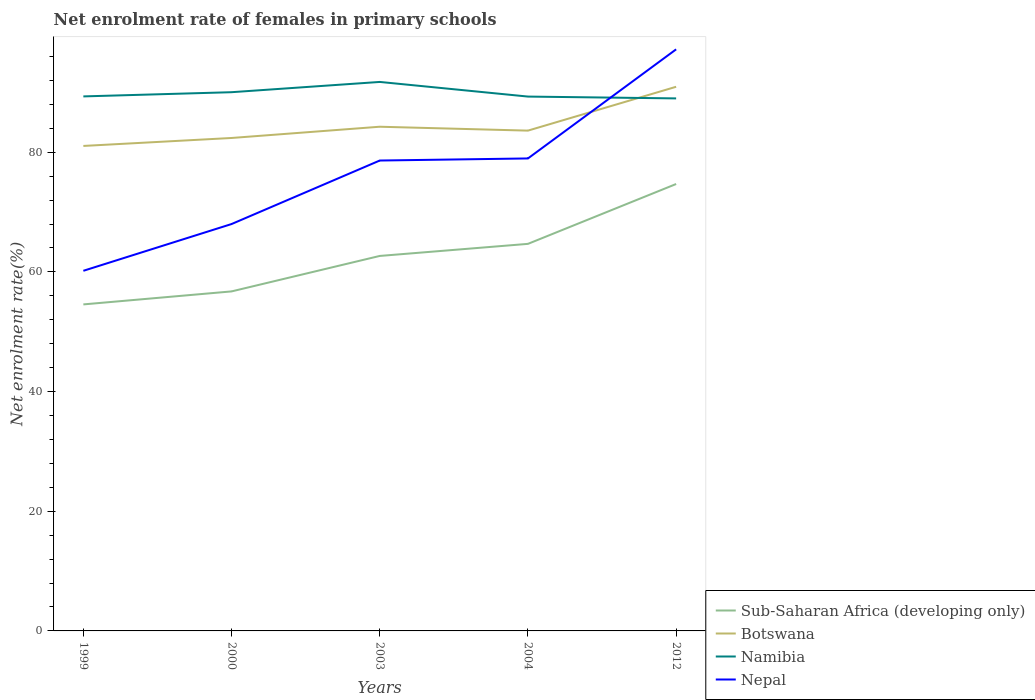How many different coloured lines are there?
Your response must be concise. 4. Is the number of lines equal to the number of legend labels?
Offer a very short reply. Yes. Across all years, what is the maximum net enrolment rate of females in primary schools in Sub-Saharan Africa (developing only)?
Make the answer very short. 54.56. What is the total net enrolment rate of females in primary schools in Botswana in the graph?
Your answer should be compact. -1.23. What is the difference between the highest and the second highest net enrolment rate of females in primary schools in Botswana?
Make the answer very short. 9.89. What is the difference between the highest and the lowest net enrolment rate of females in primary schools in Namibia?
Keep it short and to the point. 2. What is the difference between two consecutive major ticks on the Y-axis?
Provide a short and direct response. 20. Does the graph contain grids?
Make the answer very short. No. Where does the legend appear in the graph?
Provide a short and direct response. Bottom right. What is the title of the graph?
Offer a very short reply. Net enrolment rate of females in primary schools. Does "South Asia" appear as one of the legend labels in the graph?
Provide a succinct answer. No. What is the label or title of the X-axis?
Your response must be concise. Years. What is the label or title of the Y-axis?
Give a very brief answer. Net enrolment rate(%). What is the Net enrolment rate(%) of Sub-Saharan Africa (developing only) in 1999?
Ensure brevity in your answer.  54.56. What is the Net enrolment rate(%) of Botswana in 1999?
Give a very brief answer. 81.05. What is the Net enrolment rate(%) in Namibia in 1999?
Your answer should be compact. 89.32. What is the Net enrolment rate(%) of Nepal in 1999?
Provide a short and direct response. 60.18. What is the Net enrolment rate(%) in Sub-Saharan Africa (developing only) in 2000?
Ensure brevity in your answer.  56.74. What is the Net enrolment rate(%) of Botswana in 2000?
Your answer should be very brief. 82.38. What is the Net enrolment rate(%) in Namibia in 2000?
Your response must be concise. 90.03. What is the Net enrolment rate(%) in Nepal in 2000?
Offer a very short reply. 67.99. What is the Net enrolment rate(%) in Sub-Saharan Africa (developing only) in 2003?
Your answer should be compact. 62.66. What is the Net enrolment rate(%) of Botswana in 2003?
Make the answer very short. 84.26. What is the Net enrolment rate(%) in Namibia in 2003?
Offer a terse response. 91.74. What is the Net enrolment rate(%) in Nepal in 2003?
Your answer should be compact. 78.61. What is the Net enrolment rate(%) of Sub-Saharan Africa (developing only) in 2004?
Give a very brief answer. 64.68. What is the Net enrolment rate(%) of Botswana in 2004?
Keep it short and to the point. 83.61. What is the Net enrolment rate(%) of Namibia in 2004?
Offer a terse response. 89.29. What is the Net enrolment rate(%) of Nepal in 2004?
Give a very brief answer. 78.96. What is the Net enrolment rate(%) in Sub-Saharan Africa (developing only) in 2012?
Offer a very short reply. 74.68. What is the Net enrolment rate(%) in Botswana in 2012?
Ensure brevity in your answer.  90.93. What is the Net enrolment rate(%) of Namibia in 2012?
Ensure brevity in your answer.  88.99. What is the Net enrolment rate(%) of Nepal in 2012?
Ensure brevity in your answer.  97.19. Across all years, what is the maximum Net enrolment rate(%) of Sub-Saharan Africa (developing only)?
Ensure brevity in your answer.  74.68. Across all years, what is the maximum Net enrolment rate(%) of Botswana?
Provide a succinct answer. 90.93. Across all years, what is the maximum Net enrolment rate(%) of Namibia?
Your answer should be compact. 91.74. Across all years, what is the maximum Net enrolment rate(%) in Nepal?
Give a very brief answer. 97.19. Across all years, what is the minimum Net enrolment rate(%) of Sub-Saharan Africa (developing only)?
Ensure brevity in your answer.  54.56. Across all years, what is the minimum Net enrolment rate(%) in Botswana?
Ensure brevity in your answer.  81.05. Across all years, what is the minimum Net enrolment rate(%) in Namibia?
Ensure brevity in your answer.  88.99. Across all years, what is the minimum Net enrolment rate(%) in Nepal?
Offer a terse response. 60.18. What is the total Net enrolment rate(%) of Sub-Saharan Africa (developing only) in the graph?
Your answer should be very brief. 313.33. What is the total Net enrolment rate(%) in Botswana in the graph?
Offer a very short reply. 422.21. What is the total Net enrolment rate(%) in Namibia in the graph?
Your response must be concise. 449.37. What is the total Net enrolment rate(%) of Nepal in the graph?
Make the answer very short. 382.92. What is the difference between the Net enrolment rate(%) of Sub-Saharan Africa (developing only) in 1999 and that in 2000?
Provide a succinct answer. -2.17. What is the difference between the Net enrolment rate(%) in Botswana in 1999 and that in 2000?
Keep it short and to the point. -1.33. What is the difference between the Net enrolment rate(%) of Namibia in 1999 and that in 2000?
Provide a succinct answer. -0.7. What is the difference between the Net enrolment rate(%) in Nepal in 1999 and that in 2000?
Your answer should be compact. -7.81. What is the difference between the Net enrolment rate(%) in Sub-Saharan Africa (developing only) in 1999 and that in 2003?
Make the answer very short. -8.1. What is the difference between the Net enrolment rate(%) in Botswana in 1999 and that in 2003?
Give a very brief answer. -3.21. What is the difference between the Net enrolment rate(%) of Namibia in 1999 and that in 2003?
Keep it short and to the point. -2.42. What is the difference between the Net enrolment rate(%) of Nepal in 1999 and that in 2003?
Your response must be concise. -18.43. What is the difference between the Net enrolment rate(%) of Sub-Saharan Africa (developing only) in 1999 and that in 2004?
Keep it short and to the point. -10.12. What is the difference between the Net enrolment rate(%) of Botswana in 1999 and that in 2004?
Offer a very short reply. -2.56. What is the difference between the Net enrolment rate(%) of Namibia in 1999 and that in 2004?
Ensure brevity in your answer.  0.03. What is the difference between the Net enrolment rate(%) of Nepal in 1999 and that in 2004?
Give a very brief answer. -18.78. What is the difference between the Net enrolment rate(%) of Sub-Saharan Africa (developing only) in 1999 and that in 2012?
Provide a short and direct response. -20.12. What is the difference between the Net enrolment rate(%) of Botswana in 1999 and that in 2012?
Your answer should be compact. -9.89. What is the difference between the Net enrolment rate(%) in Namibia in 1999 and that in 2012?
Your answer should be very brief. 0.33. What is the difference between the Net enrolment rate(%) of Nepal in 1999 and that in 2012?
Offer a very short reply. -37.01. What is the difference between the Net enrolment rate(%) in Sub-Saharan Africa (developing only) in 2000 and that in 2003?
Your answer should be very brief. -5.93. What is the difference between the Net enrolment rate(%) in Botswana in 2000 and that in 2003?
Provide a succinct answer. -1.88. What is the difference between the Net enrolment rate(%) in Namibia in 2000 and that in 2003?
Provide a short and direct response. -1.72. What is the difference between the Net enrolment rate(%) in Nepal in 2000 and that in 2003?
Your response must be concise. -10.61. What is the difference between the Net enrolment rate(%) in Sub-Saharan Africa (developing only) in 2000 and that in 2004?
Your response must be concise. -7.94. What is the difference between the Net enrolment rate(%) in Botswana in 2000 and that in 2004?
Ensure brevity in your answer.  -1.23. What is the difference between the Net enrolment rate(%) in Namibia in 2000 and that in 2004?
Ensure brevity in your answer.  0.73. What is the difference between the Net enrolment rate(%) of Nepal in 2000 and that in 2004?
Your answer should be very brief. -10.96. What is the difference between the Net enrolment rate(%) of Sub-Saharan Africa (developing only) in 2000 and that in 2012?
Make the answer very short. -17.95. What is the difference between the Net enrolment rate(%) of Botswana in 2000 and that in 2012?
Give a very brief answer. -8.56. What is the difference between the Net enrolment rate(%) in Namibia in 2000 and that in 2012?
Ensure brevity in your answer.  1.04. What is the difference between the Net enrolment rate(%) of Nepal in 2000 and that in 2012?
Your response must be concise. -29.2. What is the difference between the Net enrolment rate(%) of Sub-Saharan Africa (developing only) in 2003 and that in 2004?
Offer a terse response. -2.02. What is the difference between the Net enrolment rate(%) in Botswana in 2003 and that in 2004?
Your response must be concise. 0.65. What is the difference between the Net enrolment rate(%) in Namibia in 2003 and that in 2004?
Provide a short and direct response. 2.45. What is the difference between the Net enrolment rate(%) in Nepal in 2003 and that in 2004?
Give a very brief answer. -0.35. What is the difference between the Net enrolment rate(%) of Sub-Saharan Africa (developing only) in 2003 and that in 2012?
Offer a terse response. -12.02. What is the difference between the Net enrolment rate(%) of Botswana in 2003 and that in 2012?
Offer a very short reply. -6.68. What is the difference between the Net enrolment rate(%) in Namibia in 2003 and that in 2012?
Provide a succinct answer. 2.75. What is the difference between the Net enrolment rate(%) in Nepal in 2003 and that in 2012?
Offer a very short reply. -18.58. What is the difference between the Net enrolment rate(%) in Sub-Saharan Africa (developing only) in 2004 and that in 2012?
Your answer should be very brief. -10. What is the difference between the Net enrolment rate(%) in Botswana in 2004 and that in 2012?
Provide a short and direct response. -7.33. What is the difference between the Net enrolment rate(%) of Namibia in 2004 and that in 2012?
Ensure brevity in your answer.  0.31. What is the difference between the Net enrolment rate(%) in Nepal in 2004 and that in 2012?
Provide a short and direct response. -18.23. What is the difference between the Net enrolment rate(%) in Sub-Saharan Africa (developing only) in 1999 and the Net enrolment rate(%) in Botswana in 2000?
Keep it short and to the point. -27.81. What is the difference between the Net enrolment rate(%) of Sub-Saharan Africa (developing only) in 1999 and the Net enrolment rate(%) of Namibia in 2000?
Make the answer very short. -35.46. What is the difference between the Net enrolment rate(%) of Sub-Saharan Africa (developing only) in 1999 and the Net enrolment rate(%) of Nepal in 2000?
Make the answer very short. -13.43. What is the difference between the Net enrolment rate(%) in Botswana in 1999 and the Net enrolment rate(%) in Namibia in 2000?
Provide a short and direct response. -8.98. What is the difference between the Net enrolment rate(%) in Botswana in 1999 and the Net enrolment rate(%) in Nepal in 2000?
Provide a short and direct response. 13.05. What is the difference between the Net enrolment rate(%) of Namibia in 1999 and the Net enrolment rate(%) of Nepal in 2000?
Provide a succinct answer. 21.33. What is the difference between the Net enrolment rate(%) in Sub-Saharan Africa (developing only) in 1999 and the Net enrolment rate(%) in Botswana in 2003?
Ensure brevity in your answer.  -29.69. What is the difference between the Net enrolment rate(%) of Sub-Saharan Africa (developing only) in 1999 and the Net enrolment rate(%) of Namibia in 2003?
Give a very brief answer. -37.18. What is the difference between the Net enrolment rate(%) in Sub-Saharan Africa (developing only) in 1999 and the Net enrolment rate(%) in Nepal in 2003?
Provide a succinct answer. -24.04. What is the difference between the Net enrolment rate(%) of Botswana in 1999 and the Net enrolment rate(%) of Namibia in 2003?
Offer a very short reply. -10.7. What is the difference between the Net enrolment rate(%) of Botswana in 1999 and the Net enrolment rate(%) of Nepal in 2003?
Provide a succinct answer. 2.44. What is the difference between the Net enrolment rate(%) in Namibia in 1999 and the Net enrolment rate(%) in Nepal in 2003?
Offer a very short reply. 10.72. What is the difference between the Net enrolment rate(%) in Sub-Saharan Africa (developing only) in 1999 and the Net enrolment rate(%) in Botswana in 2004?
Ensure brevity in your answer.  -29.04. What is the difference between the Net enrolment rate(%) of Sub-Saharan Africa (developing only) in 1999 and the Net enrolment rate(%) of Namibia in 2004?
Your response must be concise. -34.73. What is the difference between the Net enrolment rate(%) in Sub-Saharan Africa (developing only) in 1999 and the Net enrolment rate(%) in Nepal in 2004?
Keep it short and to the point. -24.39. What is the difference between the Net enrolment rate(%) in Botswana in 1999 and the Net enrolment rate(%) in Namibia in 2004?
Offer a terse response. -8.25. What is the difference between the Net enrolment rate(%) in Botswana in 1999 and the Net enrolment rate(%) in Nepal in 2004?
Your answer should be very brief. 2.09. What is the difference between the Net enrolment rate(%) in Namibia in 1999 and the Net enrolment rate(%) in Nepal in 2004?
Offer a terse response. 10.37. What is the difference between the Net enrolment rate(%) in Sub-Saharan Africa (developing only) in 1999 and the Net enrolment rate(%) in Botswana in 2012?
Your answer should be very brief. -36.37. What is the difference between the Net enrolment rate(%) in Sub-Saharan Africa (developing only) in 1999 and the Net enrolment rate(%) in Namibia in 2012?
Keep it short and to the point. -34.42. What is the difference between the Net enrolment rate(%) of Sub-Saharan Africa (developing only) in 1999 and the Net enrolment rate(%) of Nepal in 2012?
Your answer should be compact. -42.63. What is the difference between the Net enrolment rate(%) in Botswana in 1999 and the Net enrolment rate(%) in Namibia in 2012?
Give a very brief answer. -7.94. What is the difference between the Net enrolment rate(%) in Botswana in 1999 and the Net enrolment rate(%) in Nepal in 2012?
Make the answer very short. -16.14. What is the difference between the Net enrolment rate(%) of Namibia in 1999 and the Net enrolment rate(%) of Nepal in 2012?
Your response must be concise. -7.87. What is the difference between the Net enrolment rate(%) in Sub-Saharan Africa (developing only) in 2000 and the Net enrolment rate(%) in Botswana in 2003?
Offer a very short reply. -27.52. What is the difference between the Net enrolment rate(%) in Sub-Saharan Africa (developing only) in 2000 and the Net enrolment rate(%) in Namibia in 2003?
Offer a terse response. -35.01. What is the difference between the Net enrolment rate(%) in Sub-Saharan Africa (developing only) in 2000 and the Net enrolment rate(%) in Nepal in 2003?
Your answer should be very brief. -21.87. What is the difference between the Net enrolment rate(%) in Botswana in 2000 and the Net enrolment rate(%) in Namibia in 2003?
Offer a terse response. -9.37. What is the difference between the Net enrolment rate(%) of Botswana in 2000 and the Net enrolment rate(%) of Nepal in 2003?
Offer a terse response. 3.77. What is the difference between the Net enrolment rate(%) of Namibia in 2000 and the Net enrolment rate(%) of Nepal in 2003?
Offer a very short reply. 11.42. What is the difference between the Net enrolment rate(%) in Sub-Saharan Africa (developing only) in 2000 and the Net enrolment rate(%) in Botswana in 2004?
Keep it short and to the point. -26.87. What is the difference between the Net enrolment rate(%) of Sub-Saharan Africa (developing only) in 2000 and the Net enrolment rate(%) of Namibia in 2004?
Offer a terse response. -32.56. What is the difference between the Net enrolment rate(%) of Sub-Saharan Africa (developing only) in 2000 and the Net enrolment rate(%) of Nepal in 2004?
Your response must be concise. -22.22. What is the difference between the Net enrolment rate(%) in Botswana in 2000 and the Net enrolment rate(%) in Namibia in 2004?
Your response must be concise. -6.92. What is the difference between the Net enrolment rate(%) in Botswana in 2000 and the Net enrolment rate(%) in Nepal in 2004?
Offer a terse response. 3.42. What is the difference between the Net enrolment rate(%) of Namibia in 2000 and the Net enrolment rate(%) of Nepal in 2004?
Make the answer very short. 11.07. What is the difference between the Net enrolment rate(%) in Sub-Saharan Africa (developing only) in 2000 and the Net enrolment rate(%) in Botswana in 2012?
Ensure brevity in your answer.  -34.2. What is the difference between the Net enrolment rate(%) in Sub-Saharan Africa (developing only) in 2000 and the Net enrolment rate(%) in Namibia in 2012?
Your response must be concise. -32.25. What is the difference between the Net enrolment rate(%) in Sub-Saharan Africa (developing only) in 2000 and the Net enrolment rate(%) in Nepal in 2012?
Keep it short and to the point. -40.45. What is the difference between the Net enrolment rate(%) in Botswana in 2000 and the Net enrolment rate(%) in Namibia in 2012?
Keep it short and to the point. -6.61. What is the difference between the Net enrolment rate(%) in Botswana in 2000 and the Net enrolment rate(%) in Nepal in 2012?
Make the answer very short. -14.81. What is the difference between the Net enrolment rate(%) of Namibia in 2000 and the Net enrolment rate(%) of Nepal in 2012?
Offer a very short reply. -7.16. What is the difference between the Net enrolment rate(%) of Sub-Saharan Africa (developing only) in 2003 and the Net enrolment rate(%) of Botswana in 2004?
Keep it short and to the point. -20.94. What is the difference between the Net enrolment rate(%) of Sub-Saharan Africa (developing only) in 2003 and the Net enrolment rate(%) of Namibia in 2004?
Offer a terse response. -26.63. What is the difference between the Net enrolment rate(%) of Sub-Saharan Africa (developing only) in 2003 and the Net enrolment rate(%) of Nepal in 2004?
Provide a short and direct response. -16.29. What is the difference between the Net enrolment rate(%) in Botswana in 2003 and the Net enrolment rate(%) in Namibia in 2004?
Make the answer very short. -5.04. What is the difference between the Net enrolment rate(%) of Botswana in 2003 and the Net enrolment rate(%) of Nepal in 2004?
Give a very brief answer. 5.3. What is the difference between the Net enrolment rate(%) in Namibia in 2003 and the Net enrolment rate(%) in Nepal in 2004?
Your answer should be compact. 12.79. What is the difference between the Net enrolment rate(%) in Sub-Saharan Africa (developing only) in 2003 and the Net enrolment rate(%) in Botswana in 2012?
Ensure brevity in your answer.  -28.27. What is the difference between the Net enrolment rate(%) of Sub-Saharan Africa (developing only) in 2003 and the Net enrolment rate(%) of Namibia in 2012?
Your response must be concise. -26.32. What is the difference between the Net enrolment rate(%) in Sub-Saharan Africa (developing only) in 2003 and the Net enrolment rate(%) in Nepal in 2012?
Your answer should be compact. -34.53. What is the difference between the Net enrolment rate(%) of Botswana in 2003 and the Net enrolment rate(%) of Namibia in 2012?
Offer a very short reply. -4.73. What is the difference between the Net enrolment rate(%) of Botswana in 2003 and the Net enrolment rate(%) of Nepal in 2012?
Ensure brevity in your answer.  -12.93. What is the difference between the Net enrolment rate(%) in Namibia in 2003 and the Net enrolment rate(%) in Nepal in 2012?
Make the answer very short. -5.45. What is the difference between the Net enrolment rate(%) in Sub-Saharan Africa (developing only) in 2004 and the Net enrolment rate(%) in Botswana in 2012?
Your response must be concise. -26.25. What is the difference between the Net enrolment rate(%) in Sub-Saharan Africa (developing only) in 2004 and the Net enrolment rate(%) in Namibia in 2012?
Your response must be concise. -24.31. What is the difference between the Net enrolment rate(%) in Sub-Saharan Africa (developing only) in 2004 and the Net enrolment rate(%) in Nepal in 2012?
Your answer should be very brief. -32.51. What is the difference between the Net enrolment rate(%) in Botswana in 2004 and the Net enrolment rate(%) in Namibia in 2012?
Make the answer very short. -5.38. What is the difference between the Net enrolment rate(%) of Botswana in 2004 and the Net enrolment rate(%) of Nepal in 2012?
Give a very brief answer. -13.58. What is the difference between the Net enrolment rate(%) in Namibia in 2004 and the Net enrolment rate(%) in Nepal in 2012?
Give a very brief answer. -7.89. What is the average Net enrolment rate(%) of Sub-Saharan Africa (developing only) per year?
Ensure brevity in your answer.  62.67. What is the average Net enrolment rate(%) of Botswana per year?
Ensure brevity in your answer.  84.44. What is the average Net enrolment rate(%) in Namibia per year?
Your answer should be very brief. 89.87. What is the average Net enrolment rate(%) in Nepal per year?
Make the answer very short. 76.58. In the year 1999, what is the difference between the Net enrolment rate(%) in Sub-Saharan Africa (developing only) and Net enrolment rate(%) in Botswana?
Provide a short and direct response. -26.48. In the year 1999, what is the difference between the Net enrolment rate(%) in Sub-Saharan Africa (developing only) and Net enrolment rate(%) in Namibia?
Your answer should be compact. -34.76. In the year 1999, what is the difference between the Net enrolment rate(%) of Sub-Saharan Africa (developing only) and Net enrolment rate(%) of Nepal?
Your answer should be very brief. -5.62. In the year 1999, what is the difference between the Net enrolment rate(%) in Botswana and Net enrolment rate(%) in Namibia?
Your answer should be very brief. -8.28. In the year 1999, what is the difference between the Net enrolment rate(%) of Botswana and Net enrolment rate(%) of Nepal?
Your answer should be very brief. 20.87. In the year 1999, what is the difference between the Net enrolment rate(%) in Namibia and Net enrolment rate(%) in Nepal?
Provide a succinct answer. 29.14. In the year 2000, what is the difference between the Net enrolment rate(%) of Sub-Saharan Africa (developing only) and Net enrolment rate(%) of Botswana?
Provide a succinct answer. -25.64. In the year 2000, what is the difference between the Net enrolment rate(%) of Sub-Saharan Africa (developing only) and Net enrolment rate(%) of Namibia?
Give a very brief answer. -33.29. In the year 2000, what is the difference between the Net enrolment rate(%) in Sub-Saharan Africa (developing only) and Net enrolment rate(%) in Nepal?
Your answer should be very brief. -11.26. In the year 2000, what is the difference between the Net enrolment rate(%) of Botswana and Net enrolment rate(%) of Namibia?
Offer a very short reply. -7.65. In the year 2000, what is the difference between the Net enrolment rate(%) of Botswana and Net enrolment rate(%) of Nepal?
Offer a very short reply. 14.38. In the year 2000, what is the difference between the Net enrolment rate(%) in Namibia and Net enrolment rate(%) in Nepal?
Provide a short and direct response. 22.03. In the year 2003, what is the difference between the Net enrolment rate(%) of Sub-Saharan Africa (developing only) and Net enrolment rate(%) of Botswana?
Your response must be concise. -21.59. In the year 2003, what is the difference between the Net enrolment rate(%) of Sub-Saharan Africa (developing only) and Net enrolment rate(%) of Namibia?
Your answer should be compact. -29.08. In the year 2003, what is the difference between the Net enrolment rate(%) in Sub-Saharan Africa (developing only) and Net enrolment rate(%) in Nepal?
Offer a very short reply. -15.94. In the year 2003, what is the difference between the Net enrolment rate(%) of Botswana and Net enrolment rate(%) of Namibia?
Give a very brief answer. -7.49. In the year 2003, what is the difference between the Net enrolment rate(%) in Botswana and Net enrolment rate(%) in Nepal?
Keep it short and to the point. 5.65. In the year 2003, what is the difference between the Net enrolment rate(%) of Namibia and Net enrolment rate(%) of Nepal?
Provide a succinct answer. 13.13. In the year 2004, what is the difference between the Net enrolment rate(%) of Sub-Saharan Africa (developing only) and Net enrolment rate(%) of Botswana?
Your answer should be very brief. -18.92. In the year 2004, what is the difference between the Net enrolment rate(%) in Sub-Saharan Africa (developing only) and Net enrolment rate(%) in Namibia?
Your answer should be very brief. -24.61. In the year 2004, what is the difference between the Net enrolment rate(%) of Sub-Saharan Africa (developing only) and Net enrolment rate(%) of Nepal?
Your response must be concise. -14.27. In the year 2004, what is the difference between the Net enrolment rate(%) of Botswana and Net enrolment rate(%) of Namibia?
Ensure brevity in your answer.  -5.69. In the year 2004, what is the difference between the Net enrolment rate(%) in Botswana and Net enrolment rate(%) in Nepal?
Offer a terse response. 4.65. In the year 2004, what is the difference between the Net enrolment rate(%) in Namibia and Net enrolment rate(%) in Nepal?
Make the answer very short. 10.34. In the year 2012, what is the difference between the Net enrolment rate(%) in Sub-Saharan Africa (developing only) and Net enrolment rate(%) in Botswana?
Give a very brief answer. -16.25. In the year 2012, what is the difference between the Net enrolment rate(%) in Sub-Saharan Africa (developing only) and Net enrolment rate(%) in Namibia?
Make the answer very short. -14.3. In the year 2012, what is the difference between the Net enrolment rate(%) in Sub-Saharan Africa (developing only) and Net enrolment rate(%) in Nepal?
Ensure brevity in your answer.  -22.51. In the year 2012, what is the difference between the Net enrolment rate(%) in Botswana and Net enrolment rate(%) in Namibia?
Provide a succinct answer. 1.94. In the year 2012, what is the difference between the Net enrolment rate(%) in Botswana and Net enrolment rate(%) in Nepal?
Provide a short and direct response. -6.26. In the year 2012, what is the difference between the Net enrolment rate(%) in Namibia and Net enrolment rate(%) in Nepal?
Provide a short and direct response. -8.2. What is the ratio of the Net enrolment rate(%) of Sub-Saharan Africa (developing only) in 1999 to that in 2000?
Provide a succinct answer. 0.96. What is the ratio of the Net enrolment rate(%) in Botswana in 1999 to that in 2000?
Make the answer very short. 0.98. What is the ratio of the Net enrolment rate(%) of Namibia in 1999 to that in 2000?
Your response must be concise. 0.99. What is the ratio of the Net enrolment rate(%) in Nepal in 1999 to that in 2000?
Keep it short and to the point. 0.89. What is the ratio of the Net enrolment rate(%) in Sub-Saharan Africa (developing only) in 1999 to that in 2003?
Your answer should be very brief. 0.87. What is the ratio of the Net enrolment rate(%) in Botswana in 1999 to that in 2003?
Your answer should be very brief. 0.96. What is the ratio of the Net enrolment rate(%) of Namibia in 1999 to that in 2003?
Provide a succinct answer. 0.97. What is the ratio of the Net enrolment rate(%) of Nepal in 1999 to that in 2003?
Your answer should be compact. 0.77. What is the ratio of the Net enrolment rate(%) of Sub-Saharan Africa (developing only) in 1999 to that in 2004?
Provide a short and direct response. 0.84. What is the ratio of the Net enrolment rate(%) in Botswana in 1999 to that in 2004?
Provide a short and direct response. 0.97. What is the ratio of the Net enrolment rate(%) of Nepal in 1999 to that in 2004?
Your answer should be very brief. 0.76. What is the ratio of the Net enrolment rate(%) in Sub-Saharan Africa (developing only) in 1999 to that in 2012?
Give a very brief answer. 0.73. What is the ratio of the Net enrolment rate(%) of Botswana in 1999 to that in 2012?
Provide a succinct answer. 0.89. What is the ratio of the Net enrolment rate(%) of Nepal in 1999 to that in 2012?
Offer a very short reply. 0.62. What is the ratio of the Net enrolment rate(%) in Sub-Saharan Africa (developing only) in 2000 to that in 2003?
Your answer should be very brief. 0.91. What is the ratio of the Net enrolment rate(%) in Botswana in 2000 to that in 2003?
Keep it short and to the point. 0.98. What is the ratio of the Net enrolment rate(%) of Namibia in 2000 to that in 2003?
Make the answer very short. 0.98. What is the ratio of the Net enrolment rate(%) of Nepal in 2000 to that in 2003?
Make the answer very short. 0.86. What is the ratio of the Net enrolment rate(%) of Sub-Saharan Africa (developing only) in 2000 to that in 2004?
Your answer should be very brief. 0.88. What is the ratio of the Net enrolment rate(%) of Botswana in 2000 to that in 2004?
Your answer should be compact. 0.99. What is the ratio of the Net enrolment rate(%) of Namibia in 2000 to that in 2004?
Give a very brief answer. 1.01. What is the ratio of the Net enrolment rate(%) in Nepal in 2000 to that in 2004?
Provide a succinct answer. 0.86. What is the ratio of the Net enrolment rate(%) of Sub-Saharan Africa (developing only) in 2000 to that in 2012?
Give a very brief answer. 0.76. What is the ratio of the Net enrolment rate(%) of Botswana in 2000 to that in 2012?
Make the answer very short. 0.91. What is the ratio of the Net enrolment rate(%) in Namibia in 2000 to that in 2012?
Give a very brief answer. 1.01. What is the ratio of the Net enrolment rate(%) in Nepal in 2000 to that in 2012?
Ensure brevity in your answer.  0.7. What is the ratio of the Net enrolment rate(%) of Sub-Saharan Africa (developing only) in 2003 to that in 2004?
Keep it short and to the point. 0.97. What is the ratio of the Net enrolment rate(%) of Botswana in 2003 to that in 2004?
Your answer should be compact. 1.01. What is the ratio of the Net enrolment rate(%) of Namibia in 2003 to that in 2004?
Your response must be concise. 1.03. What is the ratio of the Net enrolment rate(%) in Sub-Saharan Africa (developing only) in 2003 to that in 2012?
Your answer should be compact. 0.84. What is the ratio of the Net enrolment rate(%) of Botswana in 2003 to that in 2012?
Give a very brief answer. 0.93. What is the ratio of the Net enrolment rate(%) in Namibia in 2003 to that in 2012?
Offer a terse response. 1.03. What is the ratio of the Net enrolment rate(%) in Nepal in 2003 to that in 2012?
Ensure brevity in your answer.  0.81. What is the ratio of the Net enrolment rate(%) in Sub-Saharan Africa (developing only) in 2004 to that in 2012?
Provide a succinct answer. 0.87. What is the ratio of the Net enrolment rate(%) in Botswana in 2004 to that in 2012?
Ensure brevity in your answer.  0.92. What is the ratio of the Net enrolment rate(%) in Namibia in 2004 to that in 2012?
Offer a very short reply. 1. What is the ratio of the Net enrolment rate(%) of Nepal in 2004 to that in 2012?
Your answer should be very brief. 0.81. What is the difference between the highest and the second highest Net enrolment rate(%) of Sub-Saharan Africa (developing only)?
Keep it short and to the point. 10. What is the difference between the highest and the second highest Net enrolment rate(%) in Botswana?
Ensure brevity in your answer.  6.68. What is the difference between the highest and the second highest Net enrolment rate(%) in Namibia?
Provide a succinct answer. 1.72. What is the difference between the highest and the second highest Net enrolment rate(%) of Nepal?
Your response must be concise. 18.23. What is the difference between the highest and the lowest Net enrolment rate(%) of Sub-Saharan Africa (developing only)?
Keep it short and to the point. 20.12. What is the difference between the highest and the lowest Net enrolment rate(%) in Botswana?
Offer a terse response. 9.89. What is the difference between the highest and the lowest Net enrolment rate(%) of Namibia?
Your response must be concise. 2.75. What is the difference between the highest and the lowest Net enrolment rate(%) in Nepal?
Make the answer very short. 37.01. 